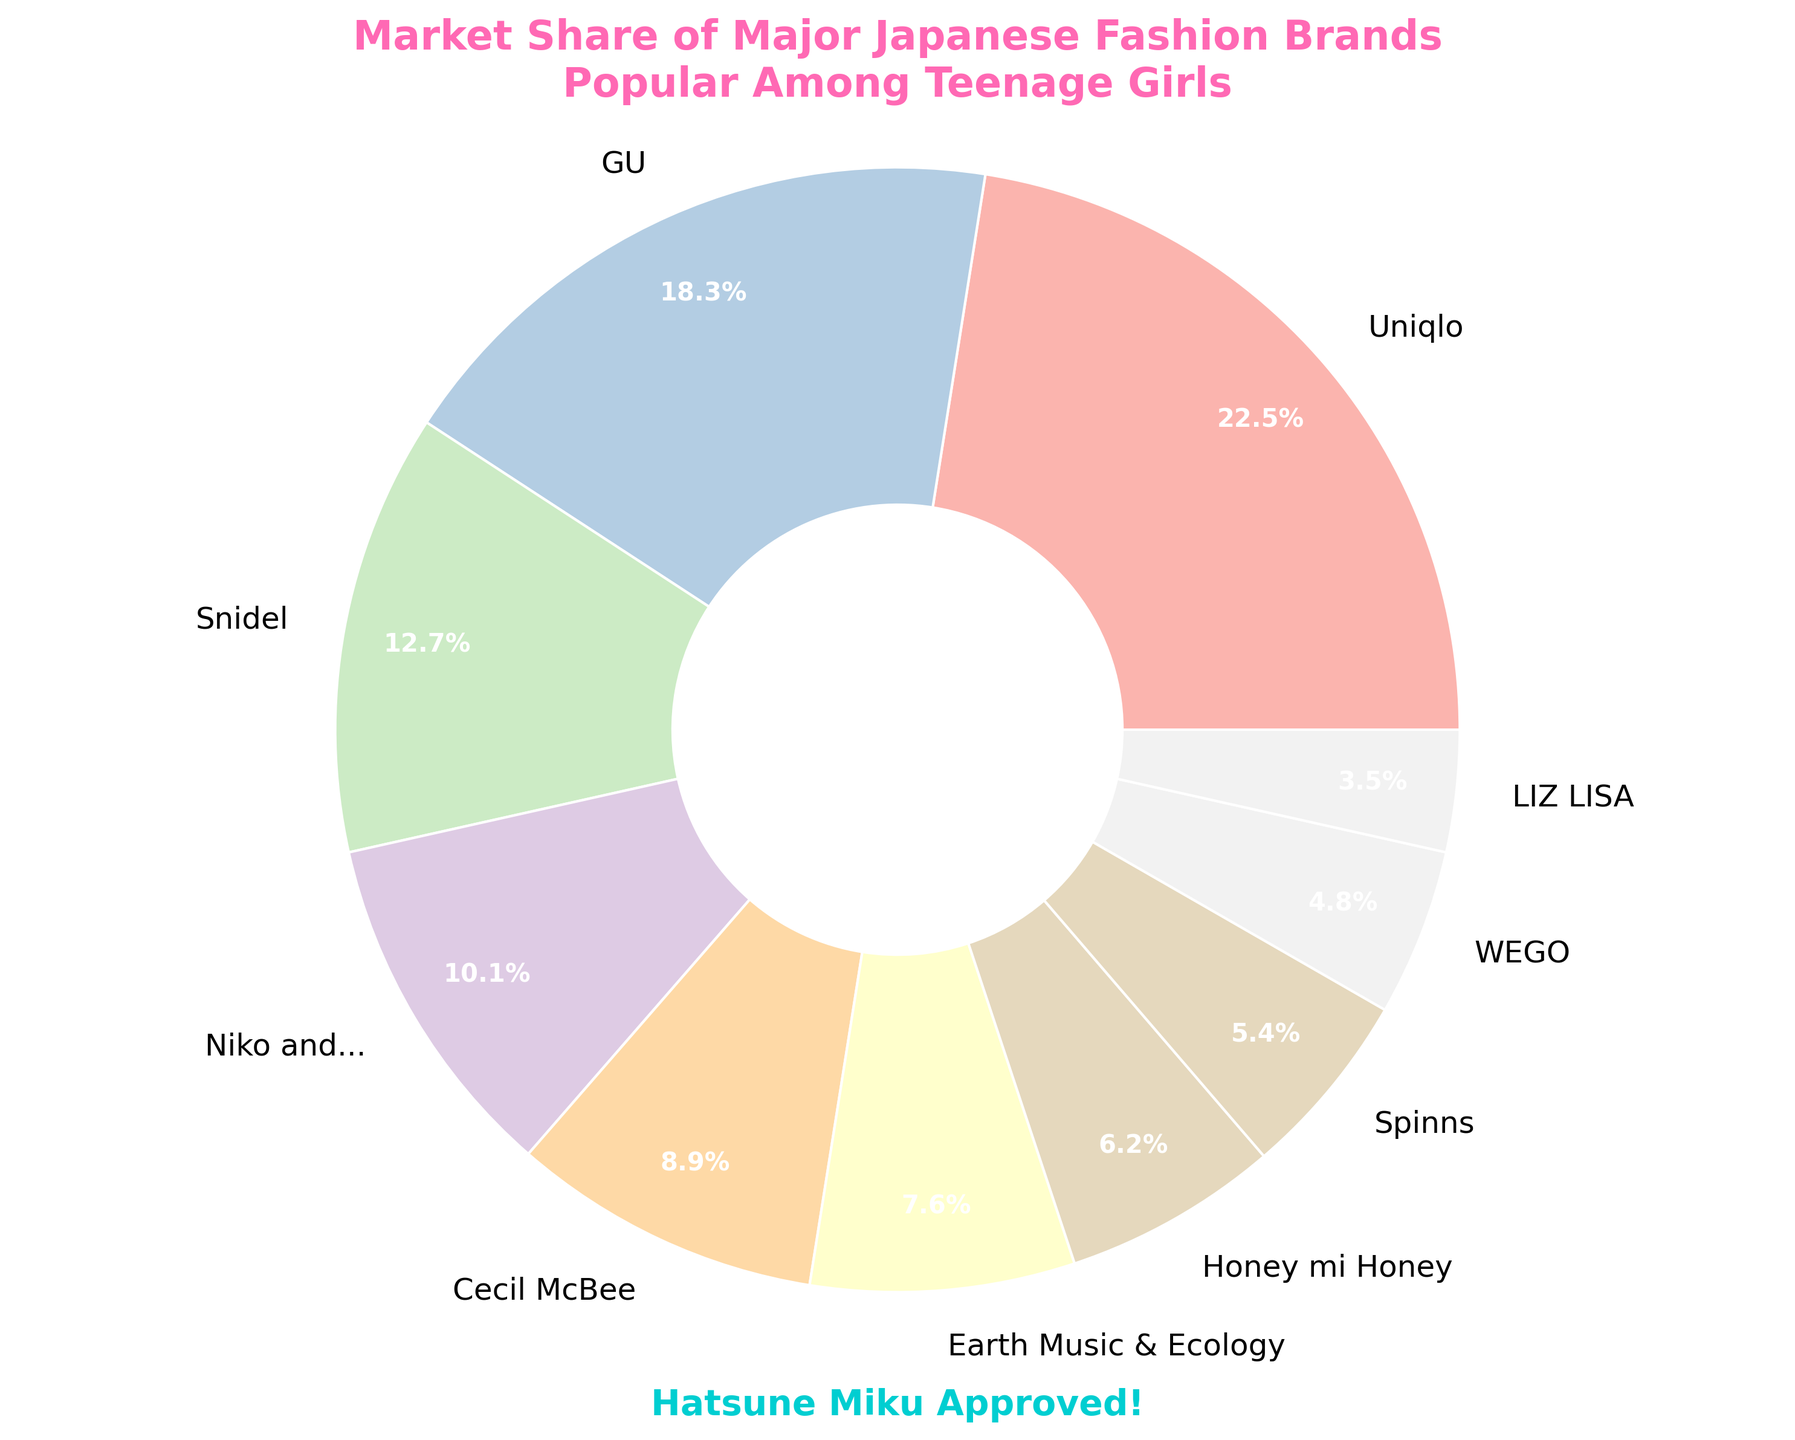What brand has the highest market share? The brand with the highest percentage slice in the pie chart represents the highest market share. By examining the largest slice, Uniqlo stands out with a 22.5% share.
Answer: Uniqlo Which brands have a combined market share of more than 30%? We need to identify and sum the market shares of the brands until the total exceeds 30%. Uniqlo (22.5%) and GU (18.3%) together make a combined share of 40.8%, which is more than 30%.
Answer: Uniqlo and GU Is the market share of Snidel more than double that of LIZ LISA? Compare the market shares of Snidel and LIZ LISA. Snidel has a 12.7% market share, while LIZ LISA has 3.5%. Doubling LIZ LISA’s share (3.5% × 2 = 7%) shows Snidel’s share is indeed more than double.
Answer: Yes Which brand has a higher market share: Honey mi Honey or Spinns? Check the percentage slices of Honey mi Honey and Spinns. Honey mi Honey has 6.2%, while Spinns has 5.4%.
Answer: Honey mi Honey Combine the market shares of Niko and... and Earth Music & Ecology. What's their total share? Sum the percentages of Niko and... (10.1%) and Earth Music & Ecology (7.6%). Total = 10.1% + 7.6% = 17.7%.
Answer: 17.7% What is the visual color of the largest market share slice? Check the pie chart for the visual color representation of the largest slice, which corresponds to Uniqlo. The exact color can't be determined from data but would be visibly seen in the chart.
Answer: Pastel color (determined visually) Of the brands mentioned, which one has the smallest share of the market? Locate the smallest percentage slice in the pie chart. LIZ LISA has the smallest market share at 3.5%.
Answer: LIZ LISA What is the total market share of the top three brands? Identify the top three brands and sum their market shares. Uniqlo (22.5%), GU (18.3%), and Snidel (12.7%) have combined shares of 22.5% + 18.3% + 12.7% = 53.5%.
Answer: 53.5% How much greater is GU’s market share compared to Cecil McBee? Subtract Cecil McBee's market share from GU's. GU has 18.3%, and Cecil McBee has 8.9%. Difference = 18.3% - 8.9% = 9.4%.
Answer: 9.4% Add up the market shares of WEGO and LIZ LISA. What's the percentage difference between their combined total and that of Uniqlo? First, sum WEGO (4.8%) and LIZ LISA (3.5%), which equals 8.3%. Then, calculate the difference from Uniqlo's 22.5%. Difference = 22.5% - 8.3% = 14.2%.
Answer: 14.2% 